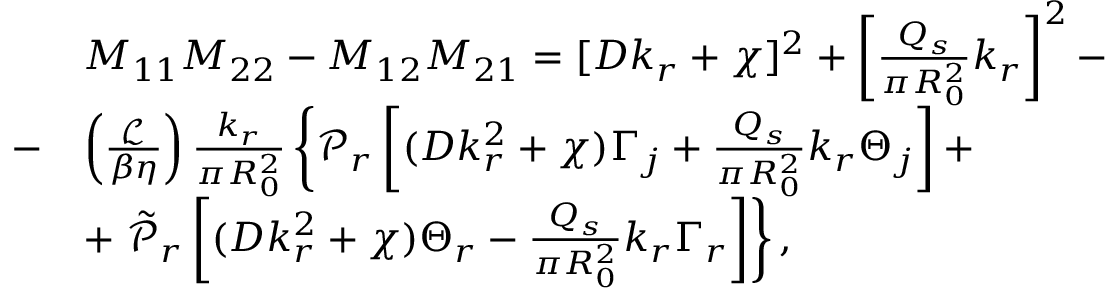<formula> <loc_0><loc_0><loc_500><loc_500>\begin{array} { r l } & { M _ { 1 1 } M _ { 2 2 } - M _ { 1 2 } M _ { 2 1 } = [ D k _ { r } + \chi ] ^ { 2 } + \left [ \frac { Q _ { s } } { \pi R _ { 0 } ^ { 2 } } k _ { r } \right ] ^ { 2 } - } \\ { - } & { \left ( \frac { \mathcal { L } } { \beta \eta } \right ) \frac { k _ { r } } { \pi R _ { 0 } ^ { 2 } } \left \{ \mathcal { P } _ { r } \left [ ( D k _ { r } ^ { 2 } + \chi ) \Gamma _ { j } + \frac { Q _ { s } } { \pi R _ { 0 } ^ { 2 } } k _ { r } \Theta _ { j } \right ] + } \\ & { + \tilde { \mathcal { P } } _ { r } \left [ ( D k _ { r } ^ { 2 } + \chi ) \Theta _ { r } - \frac { Q _ { s } } { \pi R _ { 0 } ^ { 2 } } k _ { r } \Gamma _ { r } \right ] \right \} , } \end{array}</formula> 